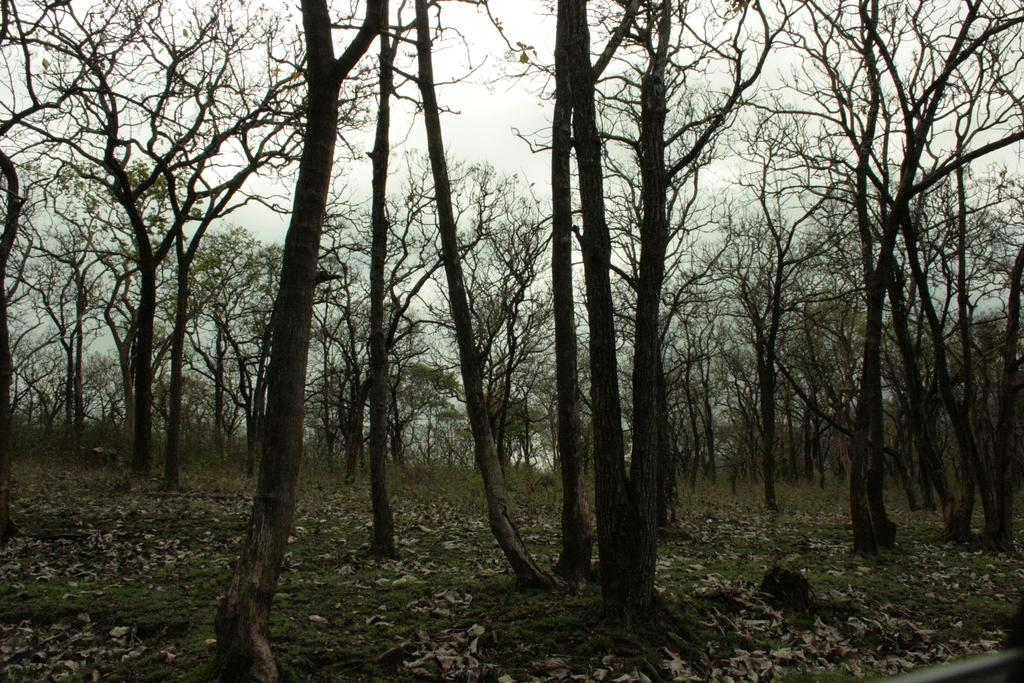What type of ground cover can be seen in the image? There is grass on the ground in the image. What else is present on the ground in the image? There are dry leaves on the ground in the image. How many trees are visible in the image? There are many trees in the image. What can be seen in the background of the image? The sky is visible in the background of the image. How does the island in the image affect the growth of the trees? There is no island present in the image; it features grass, dry leaves, trees, and the sky. What thoughts or ideas are depicted in the image? The image does not depict any thoughts or ideas; it is a visual representation of a natural environment with grass, dry leaves, trees, and the sky. 